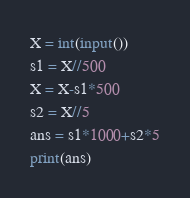<code> <loc_0><loc_0><loc_500><loc_500><_Python_>X = int(input())
s1 = X//500
X = X-s1*500
s2 = X//5
ans = s1*1000+s2*5
print(ans)</code> 